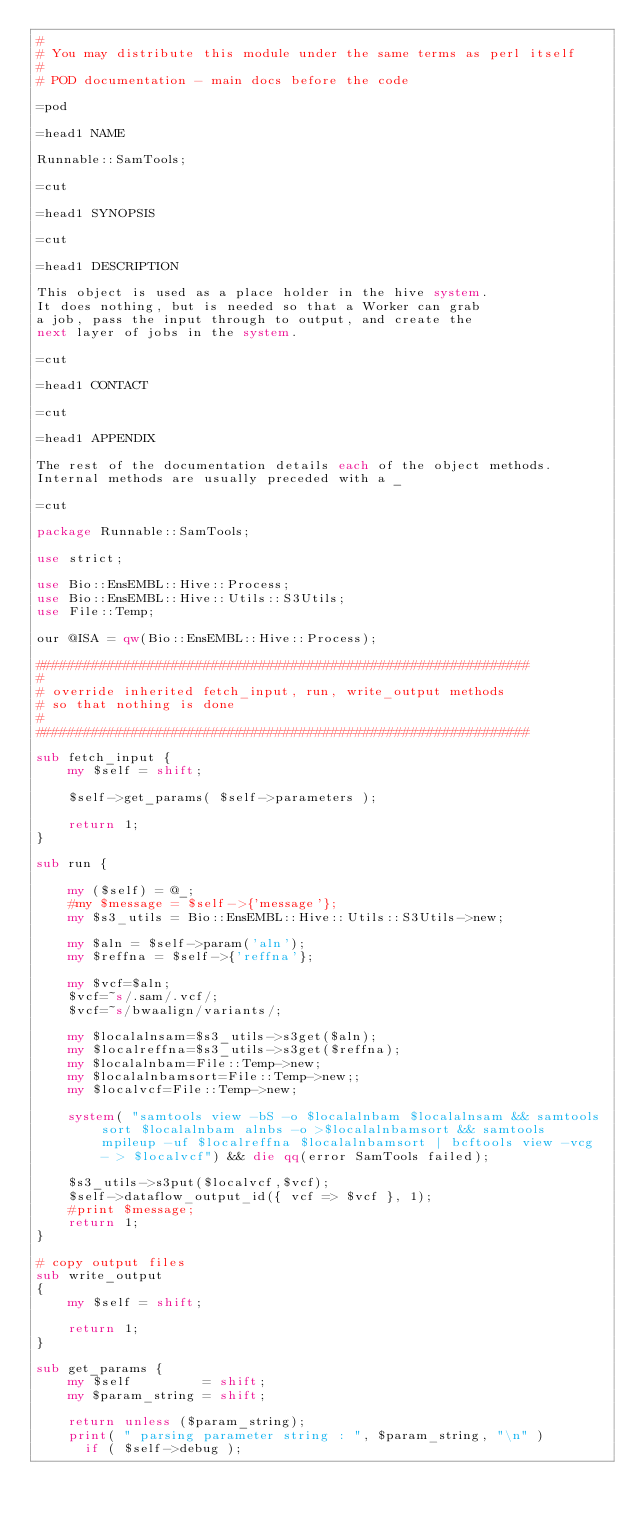<code> <loc_0><loc_0><loc_500><loc_500><_Perl_>#
# You may distribute this module under the same terms as perl itself
#
# POD documentation - main docs before the code

=pod 

=head1 NAME

Runnable::SamTools;

=cut

=head1 SYNOPSIS

=cut

=head1 DESCRIPTION

This object is used as a place holder in the hive system.
It does nothing, but is needed so that a Worker can grab
a job, pass the input through to output, and create the
next layer of jobs in the system.

=cut

=head1 CONTACT

=cut

=head1 APPENDIX

The rest of the documentation details each of the object methods. 
Internal methods are usually preceded with a _

=cut

package Runnable::SamTools;

use strict;

use Bio::EnsEMBL::Hive::Process;
use Bio::EnsEMBL::Hive::Utils::S3Utils;
use File::Temp;

our @ISA = qw(Bio::EnsEMBL::Hive::Process);

##############################################################
#
# override inherited fetch_input, run, write_output methods
# so that nothing is done
#
##############################################################

sub fetch_input {
    my $self = shift;

    $self->get_params( $self->parameters );

    return 1;
}

sub run {

    my ($self) = @_;
    #my $message = $self->{'message'};
    my $s3_utils = Bio::EnsEMBL::Hive::Utils::S3Utils->new;
    
    my $aln = $self->param('aln');
    my $reffna = $self->{'reffna'};

    my $vcf=$aln;
    $vcf=~s/.sam/.vcf/;
    $vcf=~s/bwaalign/variants/;

    my $localalnsam=$s3_utils->s3get($aln);
    my $localreffna=$s3_utils->s3get($reffna);
    my $localalnbam=File::Temp->new;
    my $localalnbamsort=File::Temp->new;;
    my $localvcf=File::Temp->new;
       
    system( "samtools view -bS -o $localalnbam $localalnsam && samtools sort $localalnbam alnbs -o >$localalnbamsort && samtools mpileup -uf $localreffna $localalnbamsort | bcftools view -vcg - > $localvcf") && die qq(error SamTools failed);
    
    $s3_utils->s3put($localvcf,$vcf);
    $self->dataflow_output_id({ vcf => $vcf }, 1);
    #print $message;
    return 1;
}

# copy output files
sub write_output
{
    my $self = shift;

    return 1;
}

sub get_params {
    my $self         = shift;
    my $param_string = shift;

    return unless ($param_string);
    print( " parsing parameter string : ", $param_string, "\n" )
      if ( $self->debug );
</code> 